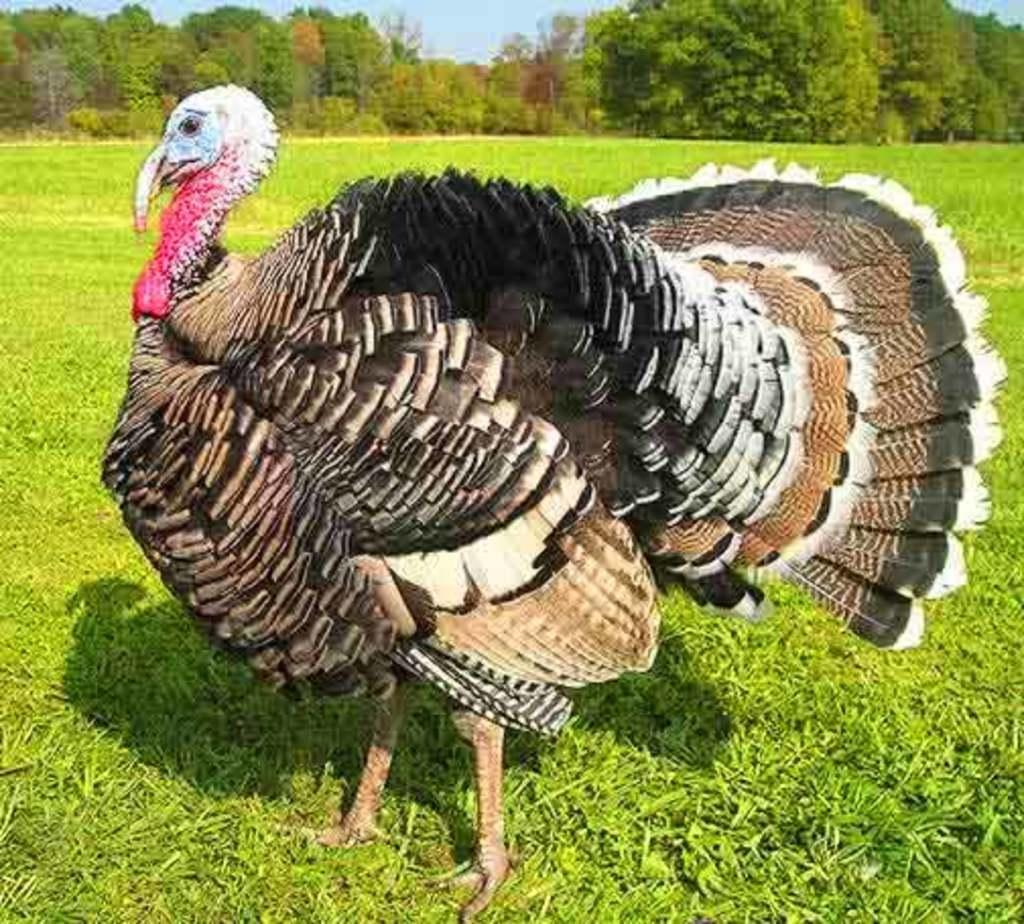In one or two sentences, can you explain what this image depicts? In the image we can see there is a turkey standing on the ground and the ground is covered with grass. Behind there are trees and the sky is clear. 